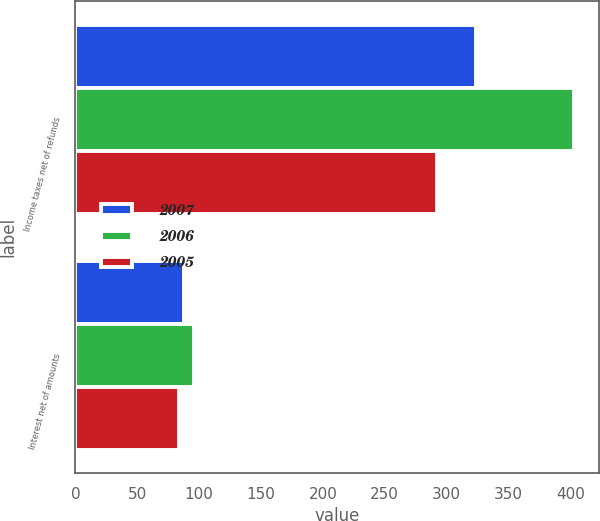Convert chart to OTSL. <chart><loc_0><loc_0><loc_500><loc_500><stacked_bar_chart><ecel><fcel>Income taxes net of refunds<fcel>Interest net of amounts<nl><fcel>2007<fcel>324<fcel>88<nl><fcel>2006<fcel>403<fcel>96<nl><fcel>2005<fcel>292<fcel>84<nl></chart> 